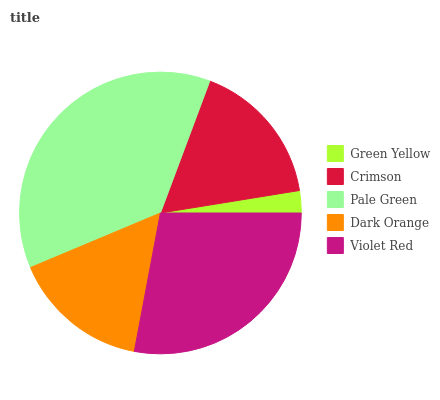Is Green Yellow the minimum?
Answer yes or no. Yes. Is Pale Green the maximum?
Answer yes or no. Yes. Is Crimson the minimum?
Answer yes or no. No. Is Crimson the maximum?
Answer yes or no. No. Is Crimson greater than Green Yellow?
Answer yes or no. Yes. Is Green Yellow less than Crimson?
Answer yes or no. Yes. Is Green Yellow greater than Crimson?
Answer yes or no. No. Is Crimson less than Green Yellow?
Answer yes or no. No. Is Crimson the high median?
Answer yes or no. Yes. Is Crimson the low median?
Answer yes or no. Yes. Is Pale Green the high median?
Answer yes or no. No. Is Dark Orange the low median?
Answer yes or no. No. 